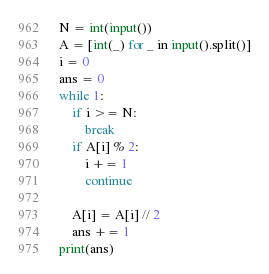Convert code to text. <code><loc_0><loc_0><loc_500><loc_500><_Python_>N = int(input())
A = [int(_) for _ in input().split()]
i = 0
ans = 0
while 1:
    if i >= N:
        break
    if A[i] % 2:
        i += 1
        continue

    A[i] = A[i] // 2
    ans += 1
print(ans)</code> 